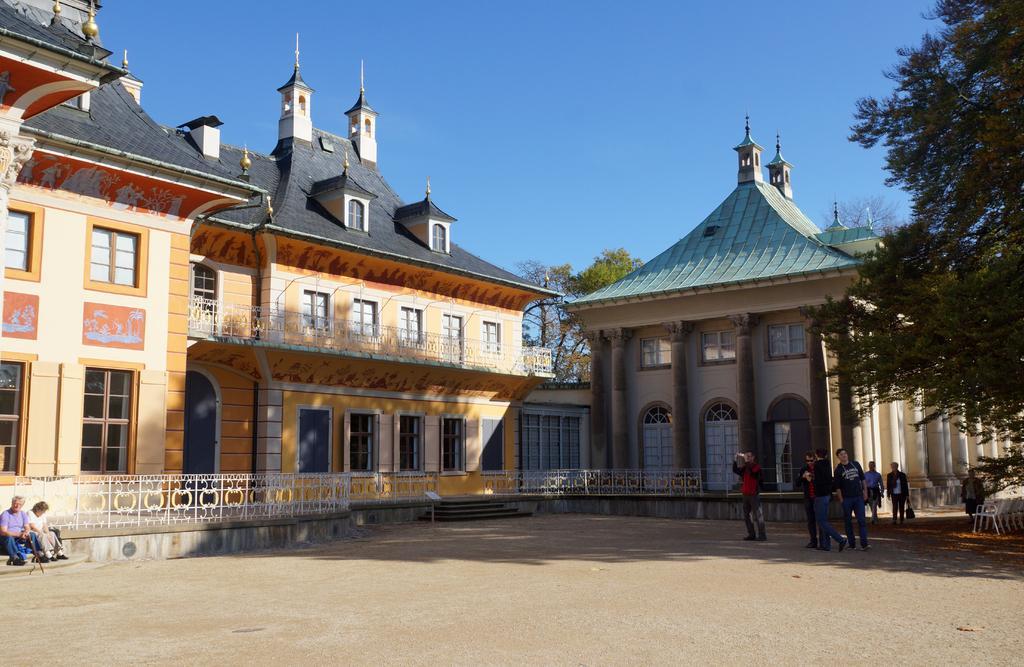How would you summarize this image in a sentence or two? In this image I can see on the left side 2 persons are sitting on the stairs. This is the building in yellow color, on the right side few men are standing and walking, there is another building and there are trees. In the middle there are chairs in this image, at the top it is the sky. 